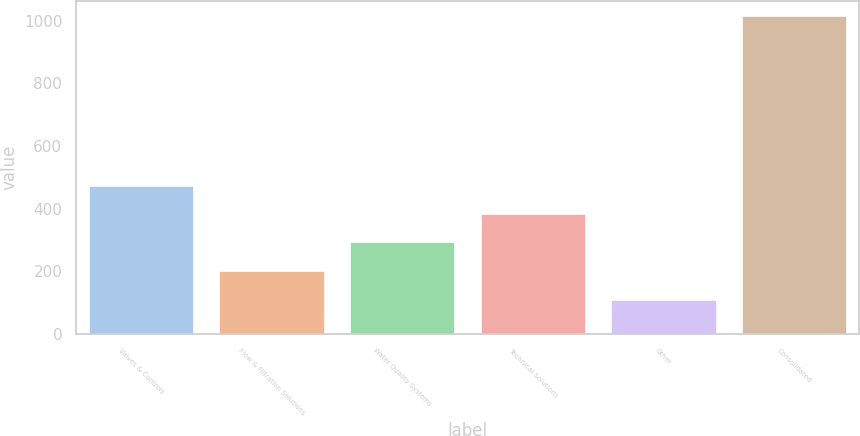Convert chart to OTSL. <chart><loc_0><loc_0><loc_500><loc_500><bar_chart><fcel>Valves & Controls<fcel>Flow & Filtration Solutions<fcel>Water Quality Systems<fcel>Technical Solutions<fcel>Other<fcel>Consolidated<nl><fcel>473.84<fcel>202.4<fcel>292.88<fcel>383.36<fcel>108.4<fcel>1013.2<nl></chart> 